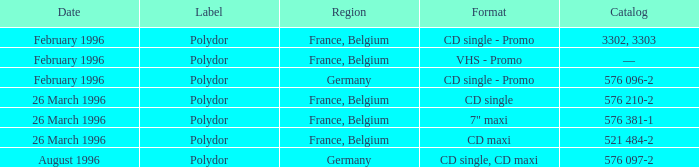Tell me the region for catalog of 576 096-2 Germany. 